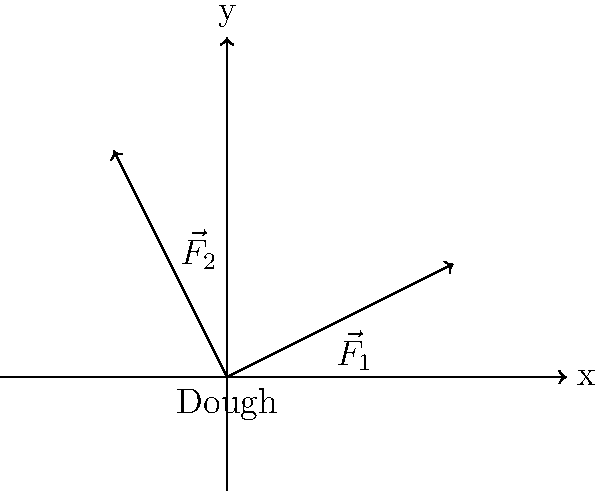When kneading dough, two forces are applied as shown in the diagram. $\vec{F}_1$ has a magnitude of 50 N and $\vec{F}_2$ has a magnitude of 40 N. Calculate the magnitude of the resultant force acting on the dough. To find the magnitude of the resultant force, we need to follow these steps:

1. Identify the components of each force:
   $\vec{F}_1$: x-component = 2, y-component = 1
   $\vec{F}_2$: x-component = -1, y-component = 2

2. Scale the components based on the given magnitudes:
   $\vec{F}_1$: x = $50 \cdot \frac{2}{\sqrt{5}}$ = 44.72 N, y = $50 \cdot \frac{1}{\sqrt{5}}$ = 22.36 N
   $\vec{F}_2$: x = $40 \cdot \frac{-1}{\sqrt{5}}$ = -17.89 N, y = $40 \cdot \frac{2}{\sqrt{5}}$ = 35.78 N

3. Sum the x and y components:
   x-resultant = 44.72 - 17.89 = 26.83 N
   y-resultant = 22.36 + 35.78 = 58.14 N

4. Calculate the magnitude of the resultant force using the Pythagorean theorem:
   $F_R = \sqrt{(26.83)^2 + (58.14)^2}$ = 64.02 N
Answer: 64.02 N 